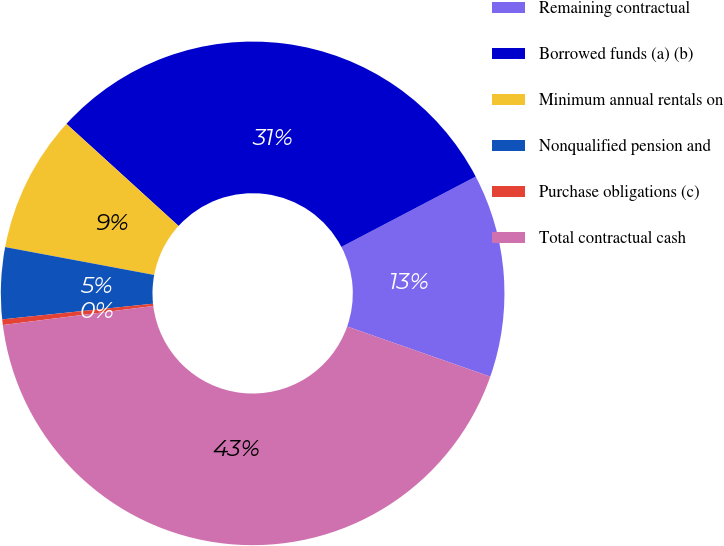<chart> <loc_0><loc_0><loc_500><loc_500><pie_chart><fcel>Remaining contractual<fcel>Borrowed funds (a) (b)<fcel>Minimum annual rentals on<fcel>Nonqualified pension and<fcel>Purchase obligations (c)<fcel>Total contractual cash<nl><fcel>13.04%<fcel>30.57%<fcel>8.81%<fcel>4.59%<fcel>0.36%<fcel>42.63%<nl></chart> 